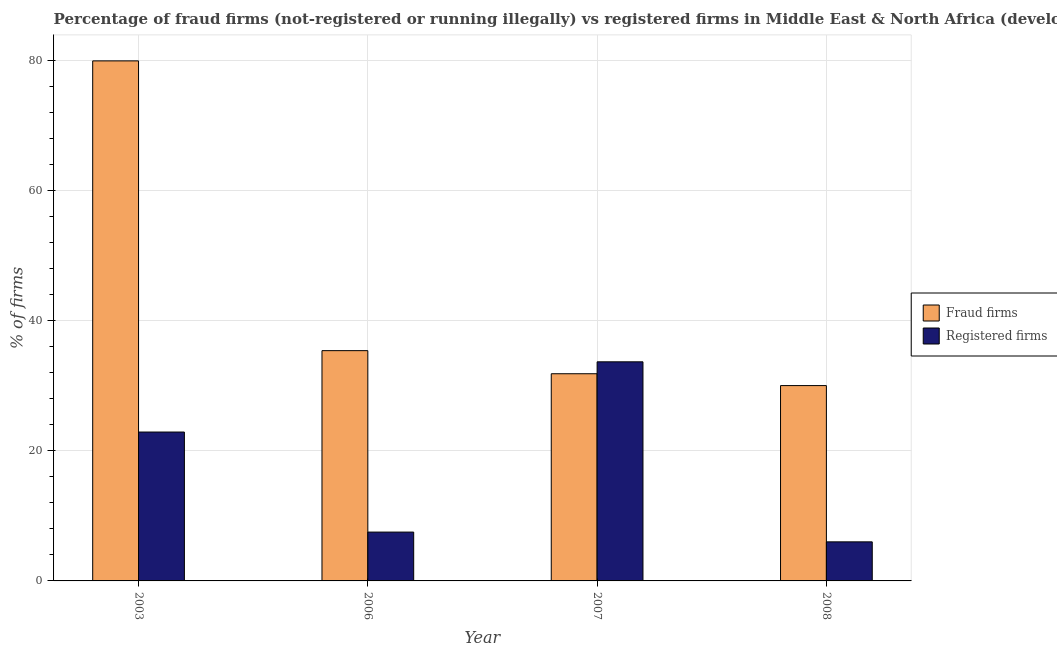How many groups of bars are there?
Your answer should be compact. 4. Are the number of bars on each tick of the X-axis equal?
Make the answer very short. Yes. How many bars are there on the 4th tick from the right?
Your response must be concise. 2. What is the label of the 1st group of bars from the left?
Offer a terse response. 2003. Across all years, what is the maximum percentage of fraud firms?
Offer a terse response. 79.87. In which year was the percentage of fraud firms minimum?
Provide a short and direct response. 2008. What is the total percentage of fraud firms in the graph?
Your answer should be very brief. 177.06. What is the difference between the percentage of fraud firms in 2007 and that in 2008?
Ensure brevity in your answer.  1.82. What is the difference between the percentage of fraud firms in 2008 and the percentage of registered firms in 2007?
Give a very brief answer. -1.82. What is the average percentage of registered firms per year?
Provide a succinct answer. 17.5. What is the ratio of the percentage of registered firms in 2006 to that in 2007?
Offer a terse response. 0.22. Is the percentage of registered firms in 2007 less than that in 2008?
Make the answer very short. No. Is the difference between the percentage of fraud firms in 2007 and 2008 greater than the difference between the percentage of registered firms in 2007 and 2008?
Give a very brief answer. No. What is the difference between the highest and the second highest percentage of fraud firms?
Offer a very short reply. 44.5. What is the difference between the highest and the lowest percentage of registered firms?
Make the answer very short. 27.65. In how many years, is the percentage of fraud firms greater than the average percentage of fraud firms taken over all years?
Your response must be concise. 1. Is the sum of the percentage of fraud firms in 2003 and 2006 greater than the maximum percentage of registered firms across all years?
Make the answer very short. Yes. What does the 2nd bar from the left in 2006 represents?
Keep it short and to the point. Registered firms. What does the 1st bar from the right in 2008 represents?
Provide a short and direct response. Registered firms. How many bars are there?
Your answer should be very brief. 8. How many years are there in the graph?
Make the answer very short. 4. What is the difference between two consecutive major ticks on the Y-axis?
Your answer should be compact. 20. Are the values on the major ticks of Y-axis written in scientific E-notation?
Your response must be concise. No. Where does the legend appear in the graph?
Your answer should be very brief. Center right. How are the legend labels stacked?
Offer a very short reply. Vertical. What is the title of the graph?
Ensure brevity in your answer.  Percentage of fraud firms (not-registered or running illegally) vs registered firms in Middle East & North Africa (developing only). Does "Primary completion rate" appear as one of the legend labels in the graph?
Provide a short and direct response. No. What is the label or title of the Y-axis?
Provide a succinct answer. % of firms. What is the % of firms of Fraud firms in 2003?
Provide a short and direct response. 79.87. What is the % of firms of Registered firms in 2003?
Give a very brief answer. 22.87. What is the % of firms of Fraud firms in 2006?
Provide a succinct answer. 35.37. What is the % of firms of Fraud firms in 2007?
Ensure brevity in your answer.  31.82. What is the % of firms of Registered firms in 2007?
Give a very brief answer. 33.65. What is the % of firms in Registered firms in 2008?
Your answer should be compact. 6. Across all years, what is the maximum % of firms of Fraud firms?
Your answer should be very brief. 79.87. Across all years, what is the maximum % of firms in Registered firms?
Give a very brief answer. 33.65. Across all years, what is the minimum % of firms in Fraud firms?
Make the answer very short. 30. What is the total % of firms of Fraud firms in the graph?
Give a very brief answer. 177.06. What is the total % of firms of Registered firms in the graph?
Your answer should be very brief. 70.02. What is the difference between the % of firms in Fraud firms in 2003 and that in 2006?
Offer a terse response. 44.5. What is the difference between the % of firms of Registered firms in 2003 and that in 2006?
Make the answer very short. 15.37. What is the difference between the % of firms in Fraud firms in 2003 and that in 2007?
Make the answer very short. 48.05. What is the difference between the % of firms in Registered firms in 2003 and that in 2007?
Offer a very short reply. -10.78. What is the difference between the % of firms of Fraud firms in 2003 and that in 2008?
Provide a succinct answer. 49.87. What is the difference between the % of firms of Registered firms in 2003 and that in 2008?
Make the answer very short. 16.87. What is the difference between the % of firms of Fraud firms in 2006 and that in 2007?
Make the answer very short. 3.55. What is the difference between the % of firms of Registered firms in 2006 and that in 2007?
Give a very brief answer. -26.15. What is the difference between the % of firms in Fraud firms in 2006 and that in 2008?
Offer a very short reply. 5.37. What is the difference between the % of firms of Fraud firms in 2007 and that in 2008?
Ensure brevity in your answer.  1.82. What is the difference between the % of firms of Registered firms in 2007 and that in 2008?
Your answer should be very brief. 27.65. What is the difference between the % of firms of Fraud firms in 2003 and the % of firms of Registered firms in 2006?
Ensure brevity in your answer.  72.37. What is the difference between the % of firms in Fraud firms in 2003 and the % of firms in Registered firms in 2007?
Provide a succinct answer. 46.22. What is the difference between the % of firms of Fraud firms in 2003 and the % of firms of Registered firms in 2008?
Ensure brevity in your answer.  73.87. What is the difference between the % of firms of Fraud firms in 2006 and the % of firms of Registered firms in 2007?
Keep it short and to the point. 1.72. What is the difference between the % of firms of Fraud firms in 2006 and the % of firms of Registered firms in 2008?
Make the answer very short. 29.37. What is the difference between the % of firms of Fraud firms in 2007 and the % of firms of Registered firms in 2008?
Provide a short and direct response. 25.82. What is the average % of firms in Fraud firms per year?
Ensure brevity in your answer.  44.26. What is the average % of firms in Registered firms per year?
Your answer should be very brief. 17.5. In the year 2003, what is the difference between the % of firms of Fraud firms and % of firms of Registered firms?
Your answer should be compact. 57. In the year 2006, what is the difference between the % of firms of Fraud firms and % of firms of Registered firms?
Provide a short and direct response. 27.87. In the year 2007, what is the difference between the % of firms of Fraud firms and % of firms of Registered firms?
Your answer should be compact. -1.83. What is the ratio of the % of firms in Fraud firms in 2003 to that in 2006?
Your answer should be very brief. 2.26. What is the ratio of the % of firms of Registered firms in 2003 to that in 2006?
Provide a short and direct response. 3.05. What is the ratio of the % of firms of Fraud firms in 2003 to that in 2007?
Your answer should be compact. 2.51. What is the ratio of the % of firms of Registered firms in 2003 to that in 2007?
Ensure brevity in your answer.  0.68. What is the ratio of the % of firms of Fraud firms in 2003 to that in 2008?
Offer a terse response. 2.66. What is the ratio of the % of firms of Registered firms in 2003 to that in 2008?
Provide a short and direct response. 3.81. What is the ratio of the % of firms in Fraud firms in 2006 to that in 2007?
Make the answer very short. 1.11. What is the ratio of the % of firms in Registered firms in 2006 to that in 2007?
Make the answer very short. 0.22. What is the ratio of the % of firms of Fraud firms in 2006 to that in 2008?
Ensure brevity in your answer.  1.18. What is the ratio of the % of firms of Registered firms in 2006 to that in 2008?
Keep it short and to the point. 1.25. What is the ratio of the % of firms in Fraud firms in 2007 to that in 2008?
Offer a terse response. 1.06. What is the ratio of the % of firms in Registered firms in 2007 to that in 2008?
Provide a succinct answer. 5.61. What is the difference between the highest and the second highest % of firms in Fraud firms?
Make the answer very short. 44.5. What is the difference between the highest and the second highest % of firms in Registered firms?
Keep it short and to the point. 10.78. What is the difference between the highest and the lowest % of firms in Fraud firms?
Offer a terse response. 49.87. What is the difference between the highest and the lowest % of firms of Registered firms?
Your answer should be compact. 27.65. 